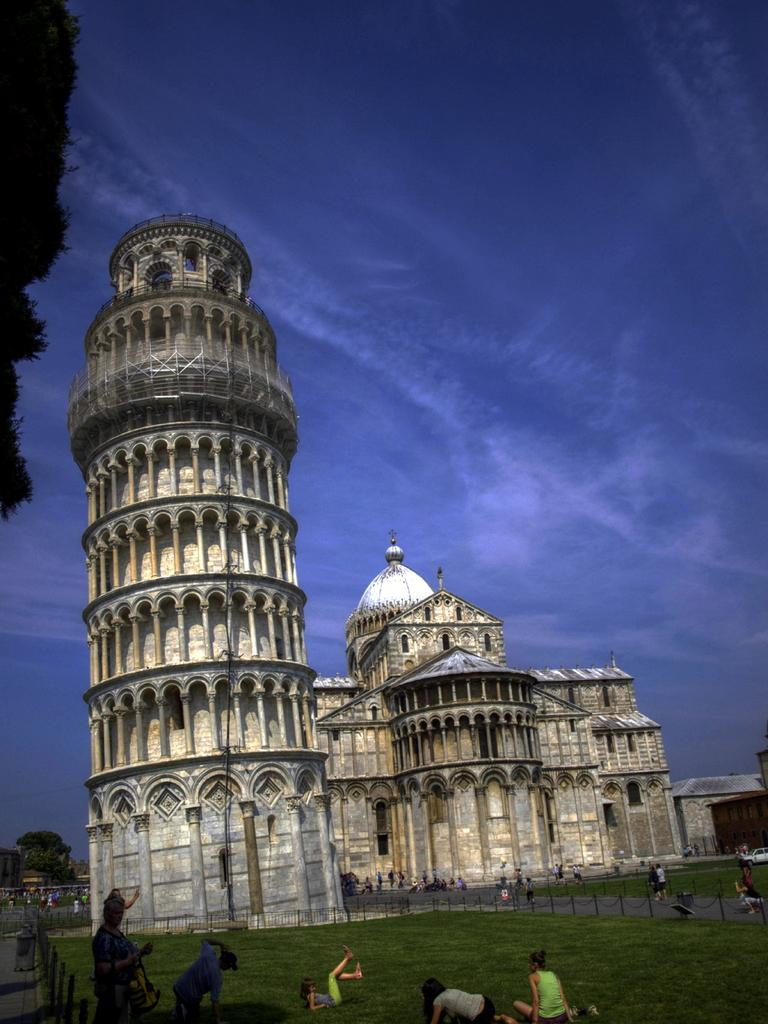What type of structures can be seen in the image? There are buildings with windows in the image. What is the purpose of the fence in the image? The purpose of the fence in the image is not specified, but it could be for enclosing an area or providing a barrier. What type of vegetation is present in the image? There are trees in the image. What is the group of people on the ground doing? The activity of the group of people on the ground is not specified in the image. What is visible in the background of the image? The sky is visible in the background of the image, and clouds are present in the sky. Can you tell me how many people are smiling in the image? There is no information about people smiling in the image; we can only see a group of people on the ground, but their facial expressions are not discernible. Is there any indication of pain or discomfort in the image? There is no indication of pain or discomfort in the image; we can only see a group of people on the ground, but their body language is not discernible. 